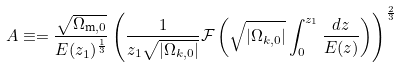<formula> <loc_0><loc_0><loc_500><loc_500>A \equiv = \frac { \sqrt { \Omega _ { \text {m} , 0 } } } { E ( z _ { 1 } ) ^ { \frac { 1 } { 3 } } } \left ( \frac { 1 } { z _ { 1 } \sqrt { | \Omega _ { k , 0 } | } } \mathcal { F } \left ( \sqrt { | \Omega _ { k , 0 } | } \int _ { 0 } ^ { z _ { 1 } } \frac { d z } { E ( z ) } \right ) \right ) ^ { \frac { 2 } { 3 } }</formula> 